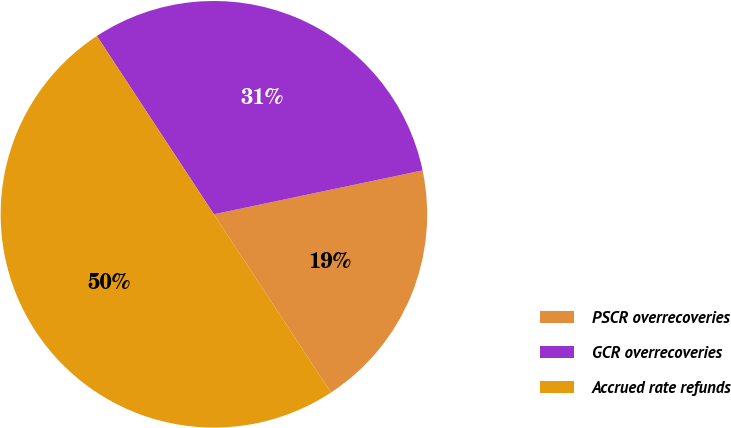<chart> <loc_0><loc_0><loc_500><loc_500><pie_chart><fcel>PSCR overrecoveries<fcel>GCR overrecoveries<fcel>Accrued rate refunds<nl><fcel>19.05%<fcel>30.95%<fcel>50.0%<nl></chart> 